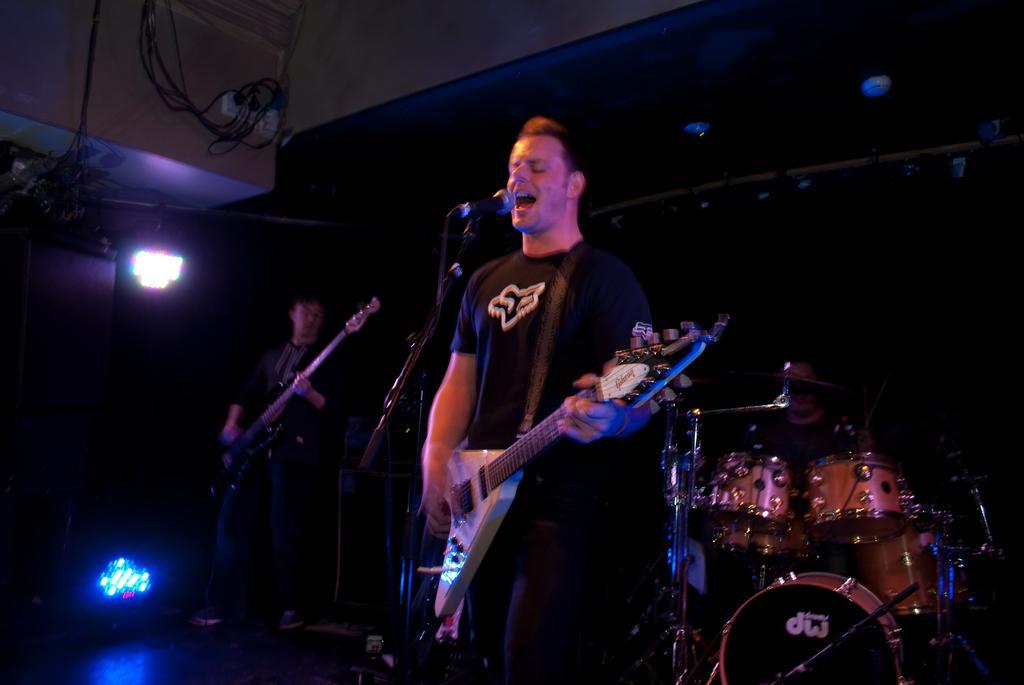How would you summarize this image in a sentence or two? In this image there is a man standing and playing a guitar and the back ground there is drums , focus light, another man standing and playing guitar. 